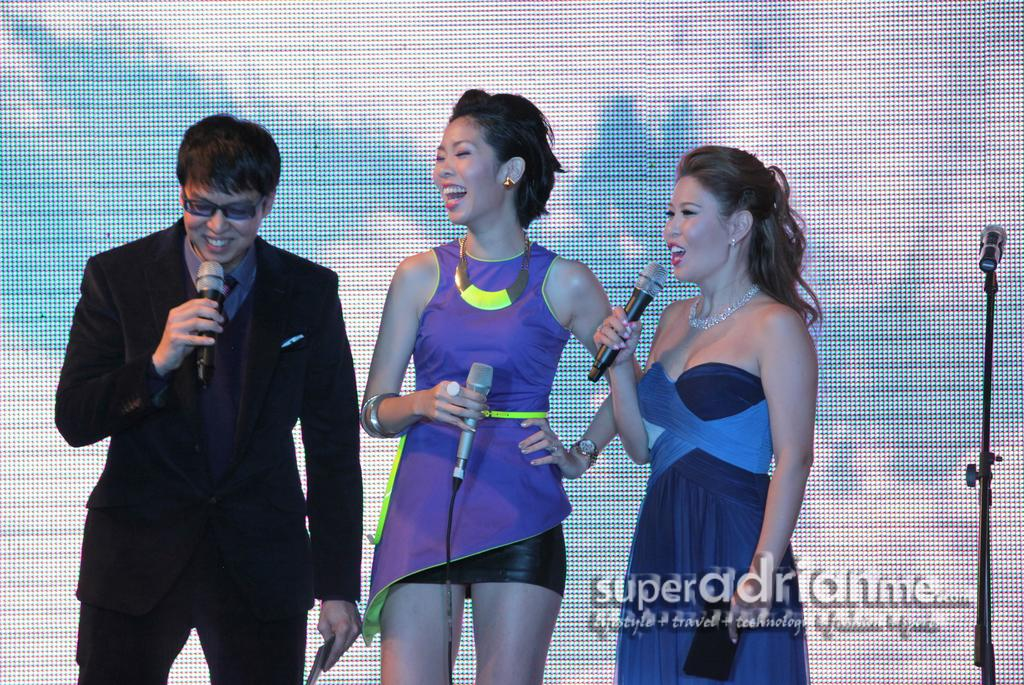How many people are in the image? There are three people in the image: two women and one man. What are the people in the image doing? The women and the man are standing and smiling. What can be seen in the background of the image? There is a screen and a microphone in the background of the image. What type of tree can be seen in the image? There is no tree present in the image. How many times does the man sneeze in the image? The man does not sneeze in the image; he is standing and smiling. 